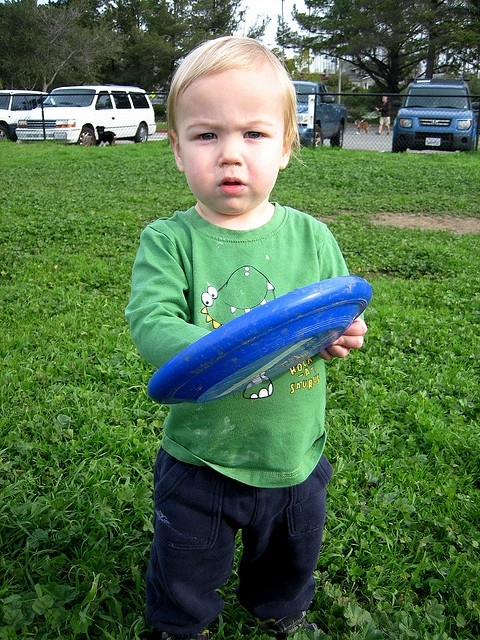Describe the objects in this image and their specific colors. I can see people in lavender, black, green, white, and lightgreen tones, frisbee in lavender, blue, navy, and darkblue tones, car in lavender, white, black, and gray tones, car in lavender, black, gray, and blue tones, and truck in lavender, gray, black, blue, and white tones in this image. 